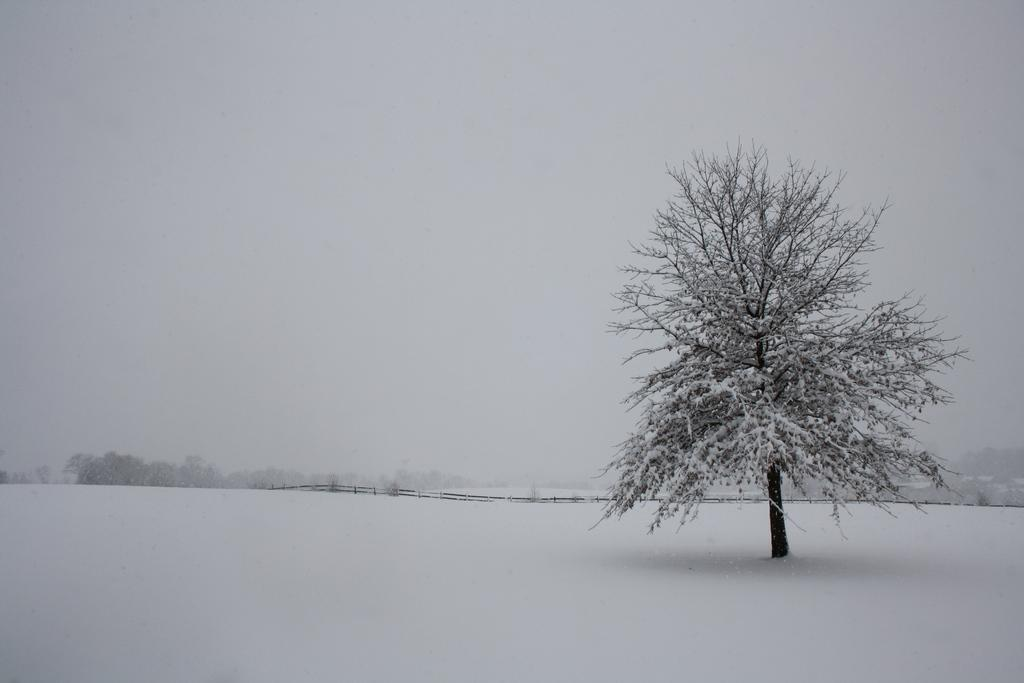What type of weather condition is depicted in the image? There is snow in the image, indicating a cold and wintry scene. What natural element can be seen in the image? There is a tree in the image. What man-made structure is present in the image? There is a fence in the image. What can be seen in the distance in the image? The sky is visible in the background of the image. What musical instrument is the queen playing in the image? There is no queen or musical instrument present in the image; it features snow, a tree, and a fence. 